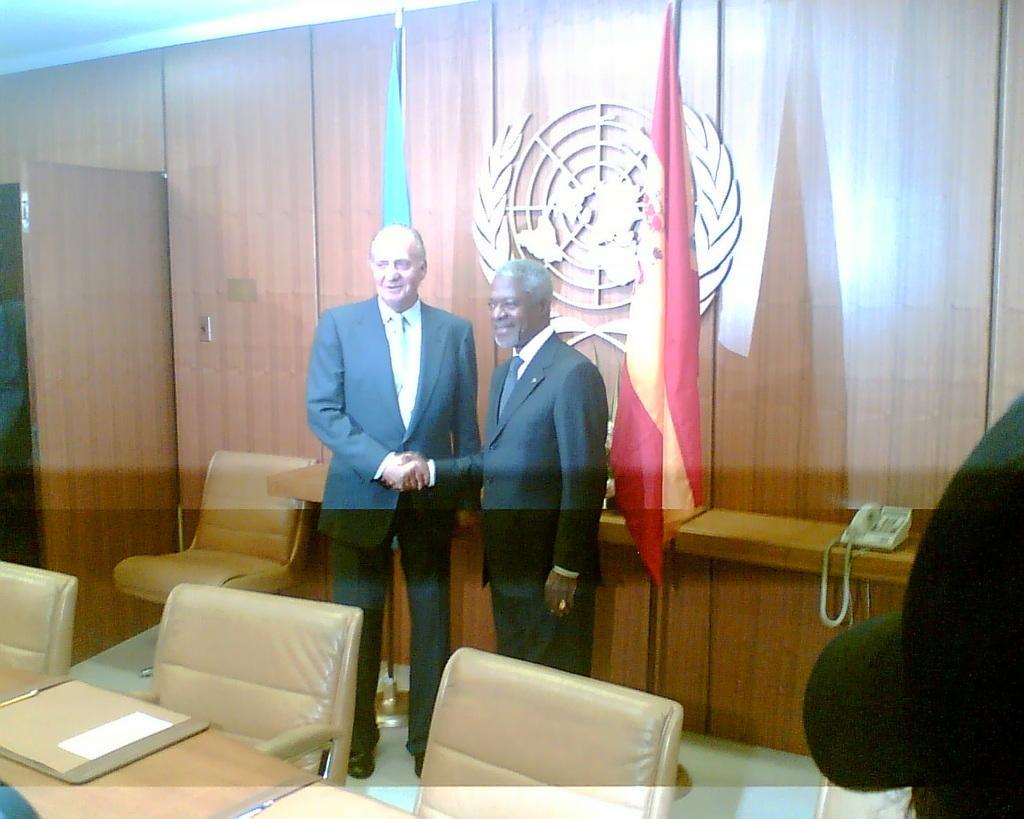Can you describe this image briefly? In this picture there are two people smiling and shaking their hands and the backdrop is some logo 